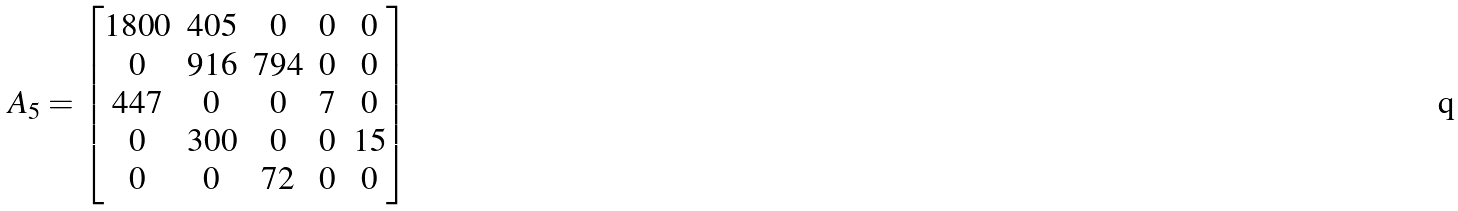Convert formula to latex. <formula><loc_0><loc_0><loc_500><loc_500>A _ { 5 } = \begin{bmatrix} 1 8 0 0 & 4 0 5 & 0 & 0 & 0 \\ 0 & 9 1 6 & 7 9 4 & 0 & 0 \\ 4 4 7 & 0 & 0 & 7 & 0 \\ 0 & 3 0 0 & 0 & 0 & 1 5 \\ 0 & 0 & 7 2 & 0 & 0 \\ \end{bmatrix}</formula> 